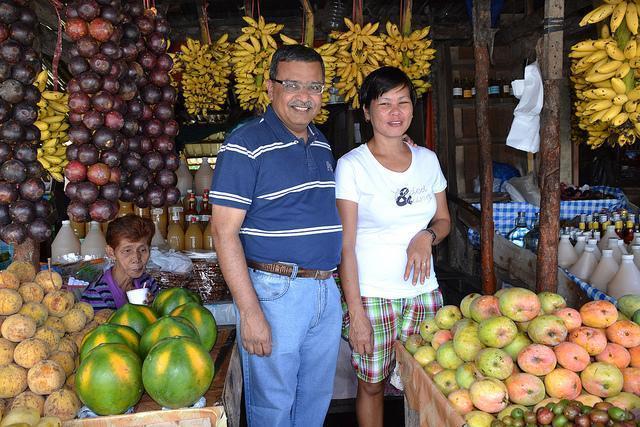How many people are in the photo?
Give a very brief answer. 3. How many bottles can be seen?
Give a very brief answer. 1. How many bananas are in the picture?
Give a very brief answer. 4. 